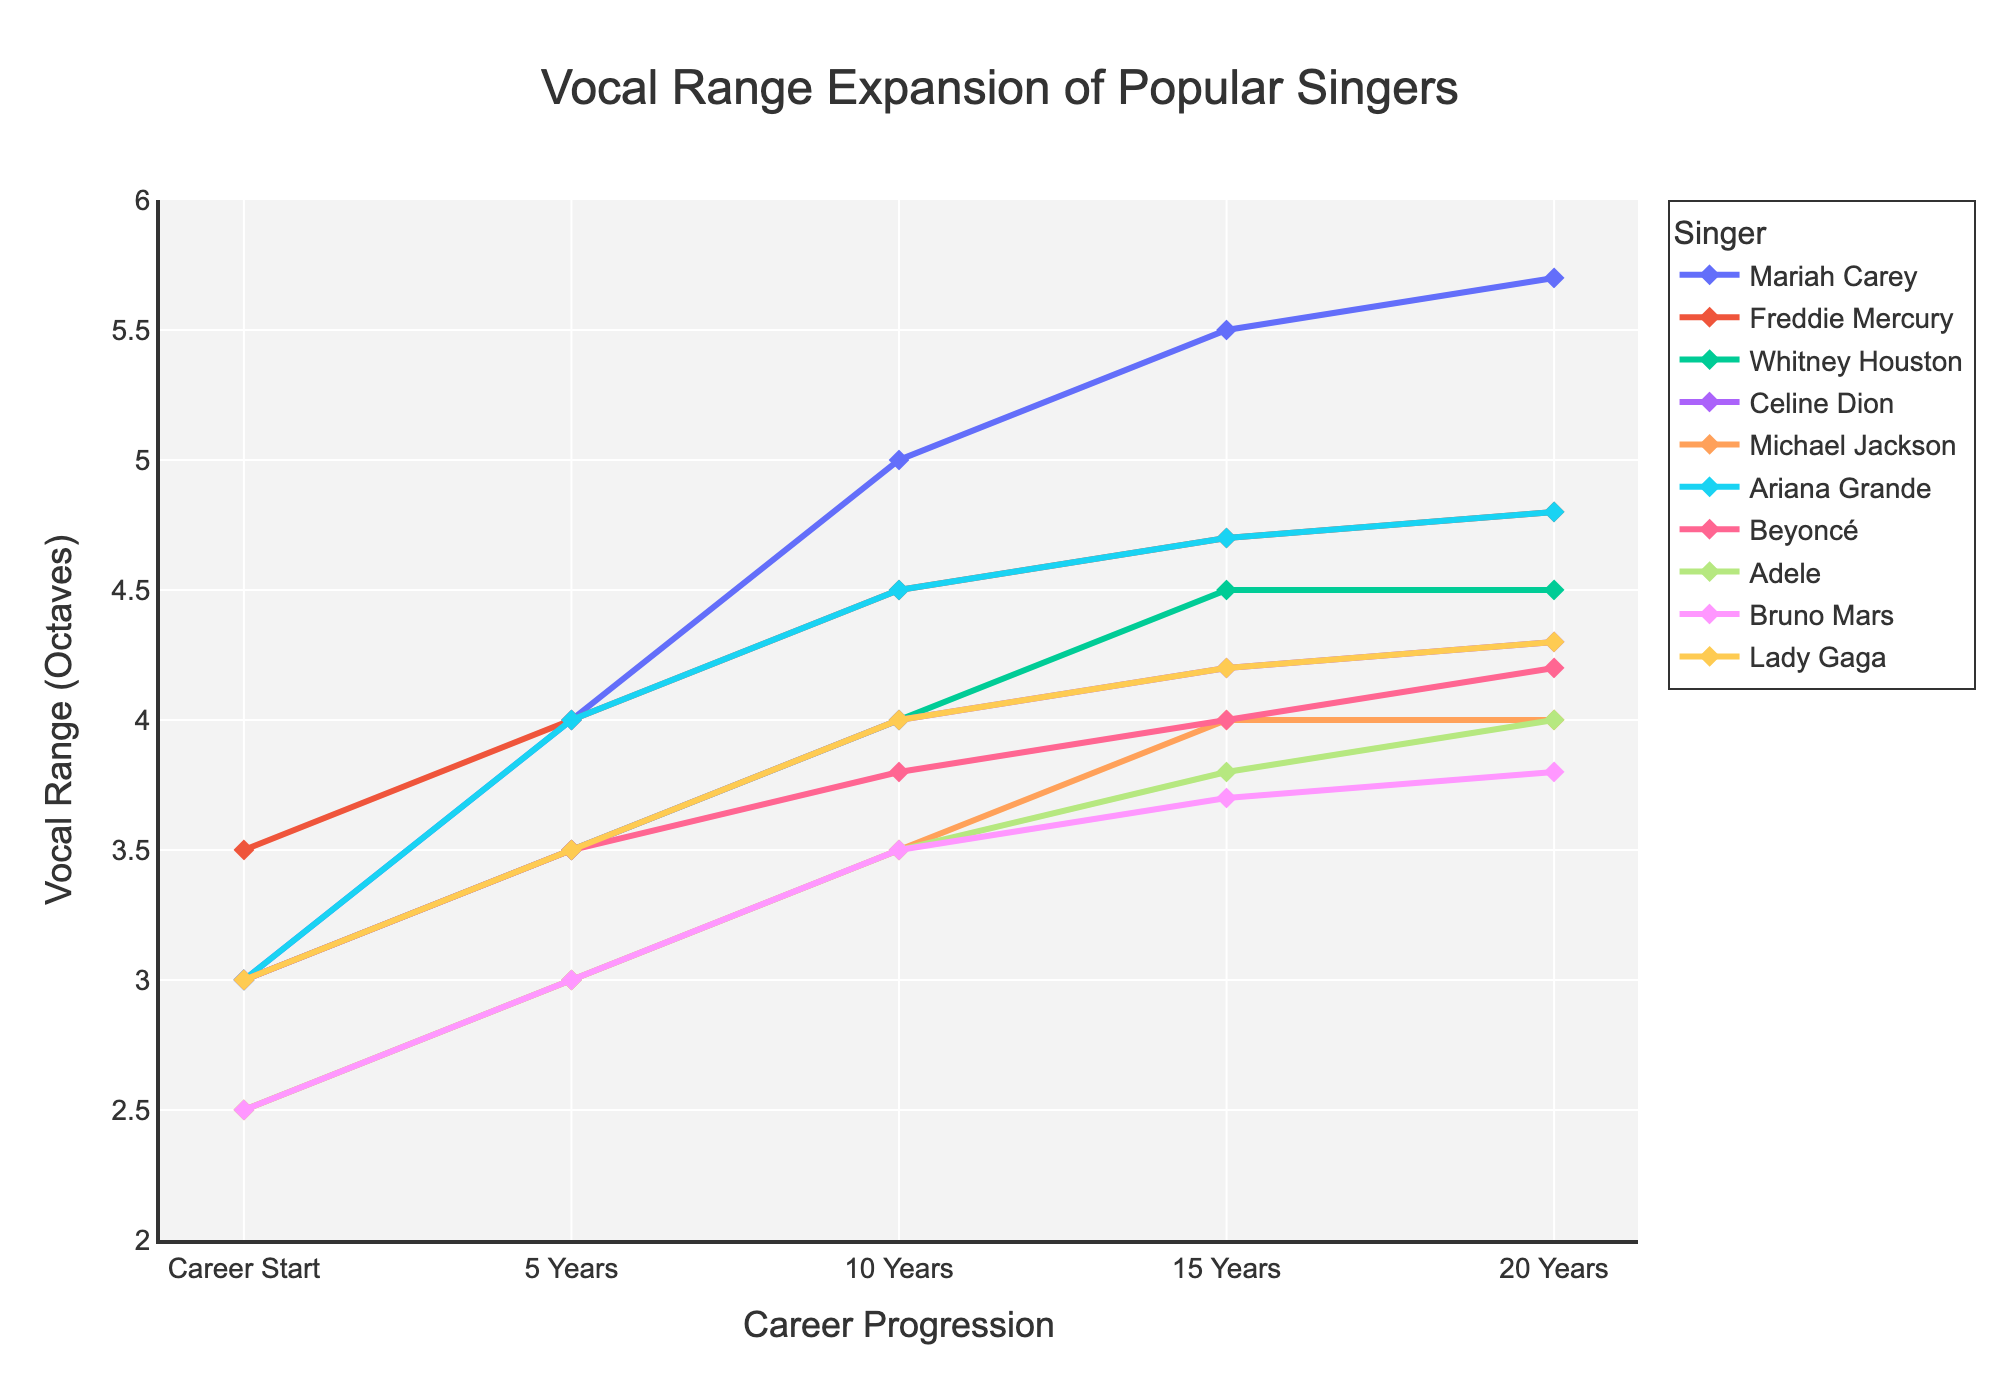What is the vocal range of Freddie Mercury at the Career Start and 5 Years? Looking at the line corresponding to Freddie Mercury, his vocal range at the Career Start is 3.5 octaves, and at 5 Years, it is 4 octaves.
Answer: 3.5 octaves and 4 octaves Who has the highest vocal range at the 20 Years mark? Observing the 20 Years data points, Mariah Carey has the highest vocal range at 20 Years with 5.7 octaves.
Answer: Mariah Carey By how much has Beyoncé's vocal range increased from Career Start to 15 Years? Beyoncé's vocal range at Career Start is 3 octaves, and at 15 Years it is 4 octaves. The increase is 4 - 3 = 1 octave.
Answer: 1 octave What is the average vocal range of Celine Dion at 5 Years, 10 Years, and 15 Years? Adding Celine Dion’s vocal ranges at 5 Years (3.5), 10 Years (4), and 15 Years (4.2) and then dividing by 3 (3.5 + 4 + 4.2) / 3 = 3.9 octaves.
Answer: 3.9 octaves Between Whitney Houston and Michael Jackson, whose vocal range expanded more over their careers? Whitney Houston's vocal range increased from 3 to 4.5 octaves (an increase of 1.5 octaves). Michael Jackson’s vocal range increased from 2.5 to 4 octaves (an increase of 1.5 octaves). Both expanded their range by the same amount.
Answer: Both the same Which singers started their careers with a vocal range of 3 octaves? From the Career Start data points, Mariah Carey, Whitney Houston, Celine Dion, Ariana Grande, Beyoncé, and Lady Gaga started with a vocal range of 3 octaves.
Answer: Mariah Carey, Whitney Houston, Celine Dion, Ariana Grande, Beyoncé, Lady Gaga How much did Adele's vocal range increase between 10 Years and 20 Years? Adele's vocal range at 10 Years is 3.5 octaves, and at 20 Years it is 4 octaves. The increase is 4 - 3.5 = 0.5 octaves.
Answer: 0.5 octaves Which singer has the steepest increase in vocal range in the first 10 years? According to the slopes observed in the first 10 years, Mariah Carey shows the steepest increase, going from 3 to 5 octaves. This is an increase of 2 octaves over the first 10 years.
Answer: Mariah Carey Who has a constant vocal range for the longest period in their career? Whitney Houston has a constant vocal range from 15 Years to 20 Years maintaining 4.5 octaves.
Answer: Whitney Houston Compare the vocal range of Lady Gaga at 5 Years and Bruno Mars at 10 Years. Who has the higher vocal range? Lady Gaga's vocal range at 5 years is 3.5 octaves, while Bruno Mars's vocal range at 10 years is 3.5 octaves. Both have the same vocal range at these points.
Answer: Same 